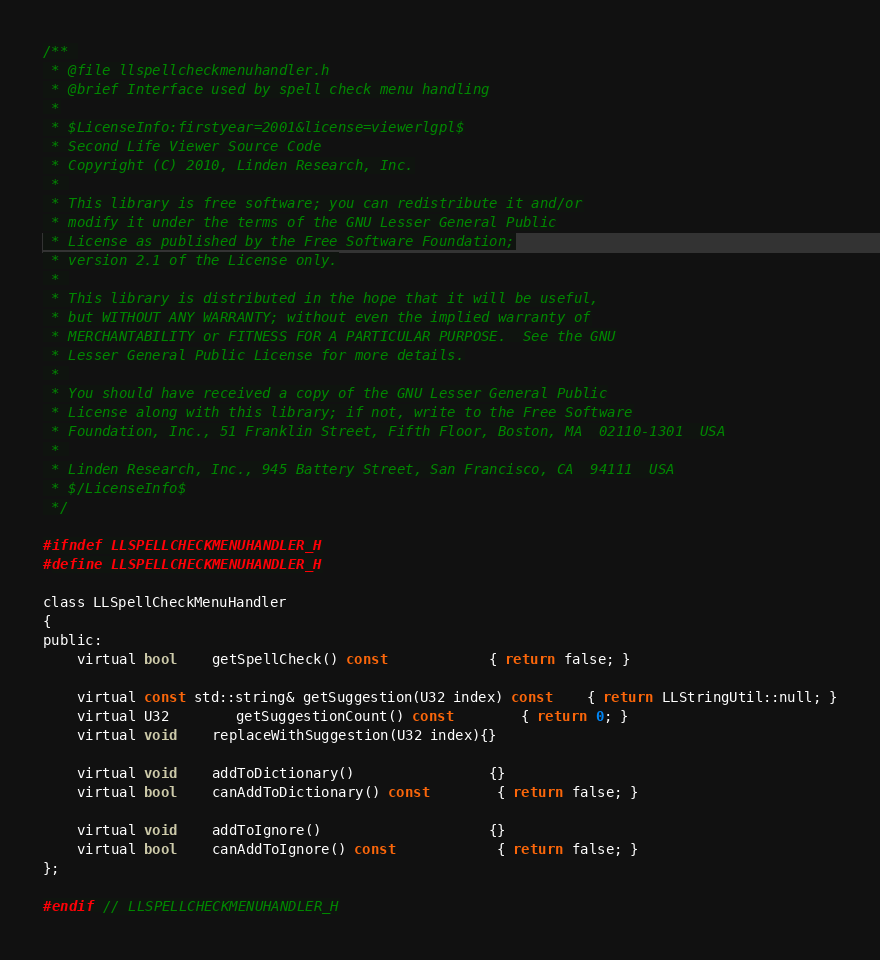Convert code to text. <code><loc_0><loc_0><loc_500><loc_500><_C_>/** 
 * @file llspellcheckmenuhandler.h
 * @brief Interface used by spell check menu handling
 *
 * $LicenseInfo:firstyear=2001&license=viewerlgpl$
 * Second Life Viewer Source Code
 * Copyright (C) 2010, Linden Research, Inc.
 * 
 * This library is free software; you can redistribute it and/or
 * modify it under the terms of the GNU Lesser General Public
 * License as published by the Free Software Foundation;
 * version 2.1 of the License only.
 * 
 * This library is distributed in the hope that it will be useful,
 * but WITHOUT ANY WARRANTY; without even the implied warranty of
 * MERCHANTABILITY or FITNESS FOR A PARTICULAR PURPOSE.  See the GNU
 * Lesser General Public License for more details.
 * 
 * You should have received a copy of the GNU Lesser General Public
 * License along with this library; if not, write to the Free Software
 * Foundation, Inc., 51 Franklin Street, Fifth Floor, Boston, MA  02110-1301  USA
 * 
 * Linden Research, Inc., 945 Battery Street, San Francisco, CA  94111  USA
 * $/LicenseInfo$
 */

#ifndef LLSPELLCHECKMENUHANDLER_H
#define LLSPELLCHECKMENUHANDLER_H

class LLSpellCheckMenuHandler
{
public:
	virtual bool	getSpellCheck() const			{ return false; }

	virtual const std::string& getSuggestion(U32 index) const	{ return LLStringUtil::null; }
	virtual U32		getSuggestionCount() const		{ return 0; }
	virtual void	replaceWithSuggestion(U32 index){}

	virtual void	addToDictionary()				{}
	virtual bool	canAddToDictionary() const		{ return false; }

	virtual void	addToIgnore()					{}
	virtual bool	canAddToIgnore() const			{ return false; }
};

#endif // LLSPELLCHECKMENUHANDLER_H
</code> 